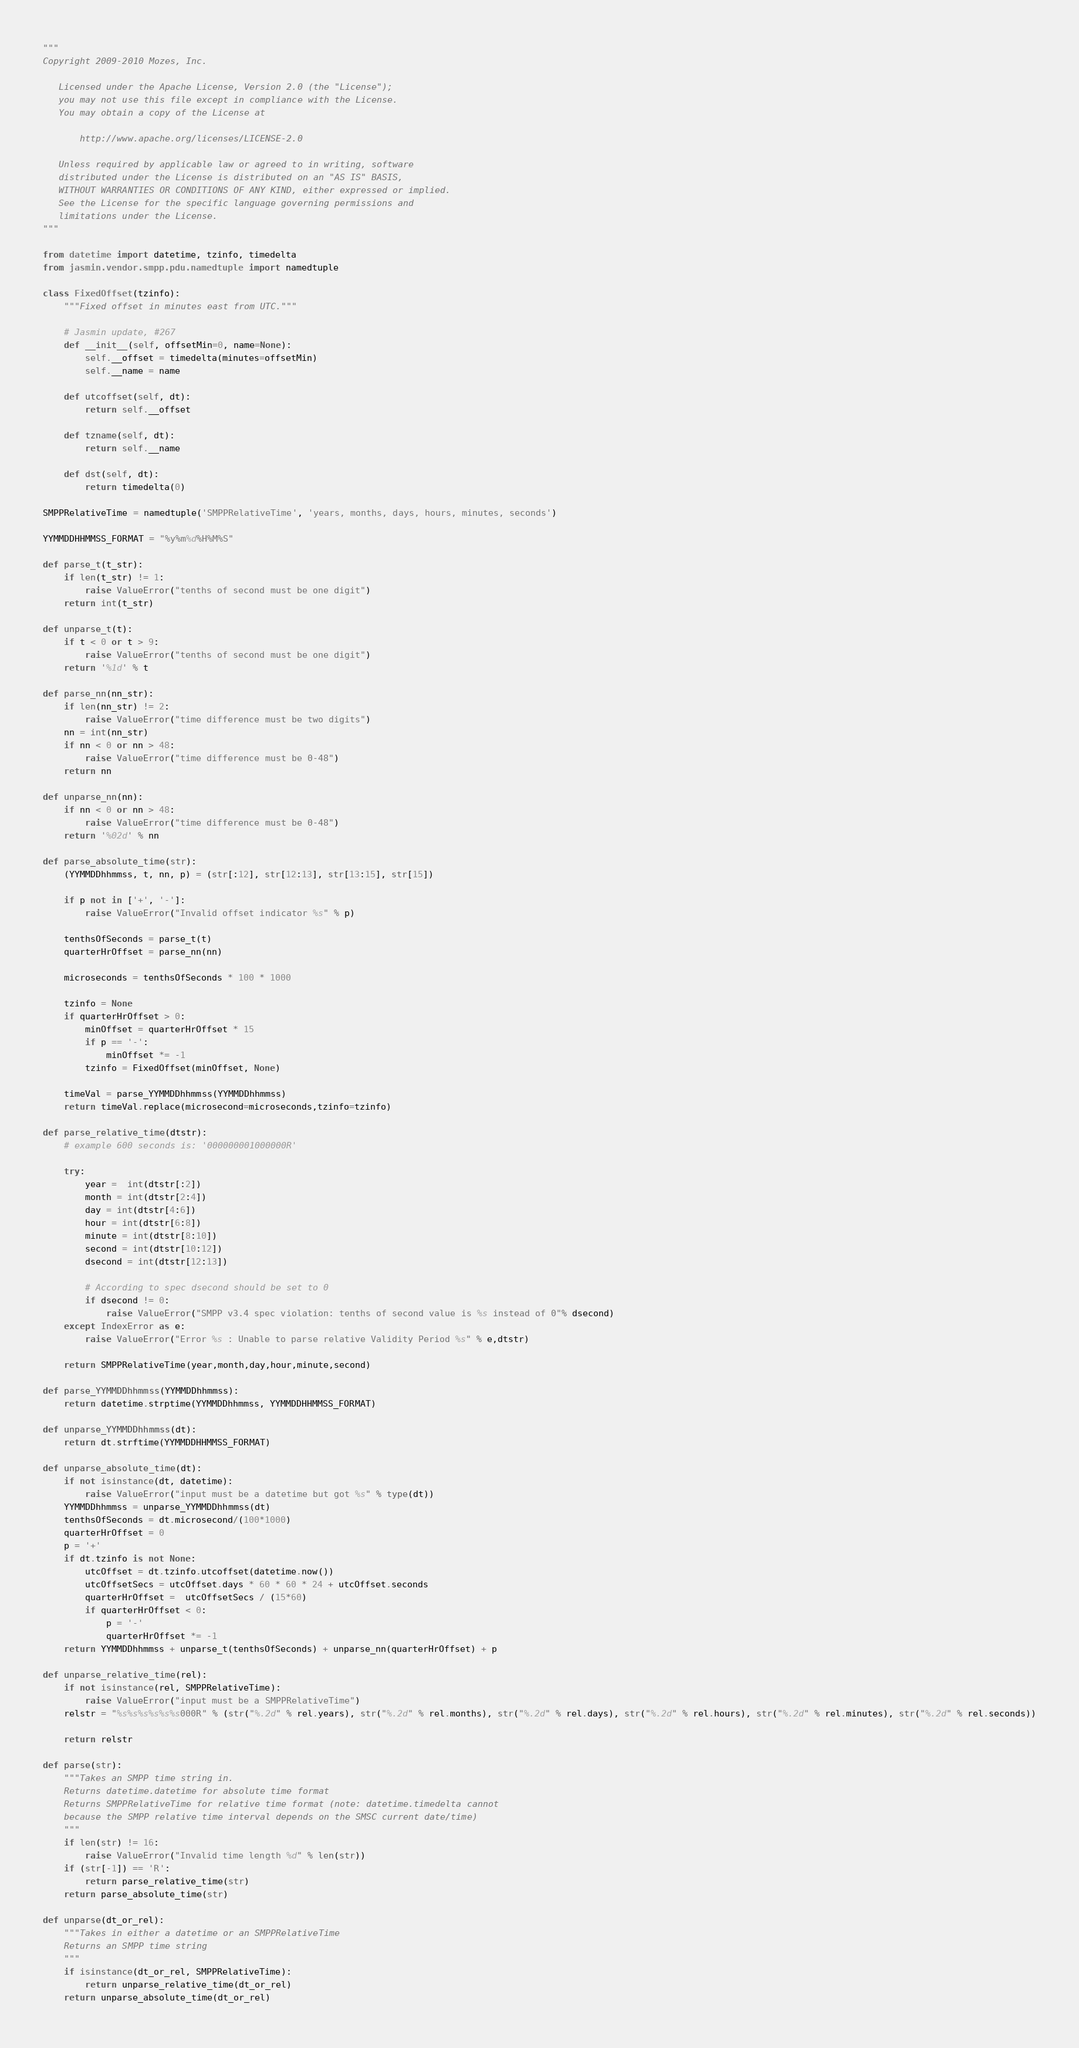<code> <loc_0><loc_0><loc_500><loc_500><_Python_>"""
Copyright 2009-2010 Mozes, Inc.

   Licensed under the Apache License, Version 2.0 (the "License");
   you may not use this file except in compliance with the License.
   You may obtain a copy of the License at

       http://www.apache.org/licenses/LICENSE-2.0

   Unless required by applicable law or agreed to in writing, software
   distributed under the License is distributed on an "AS IS" BASIS,
   WITHOUT WARRANTIES OR CONDITIONS OF ANY KIND, either expressed or implied.
   See the License for the specific language governing permissions and
   limitations under the License.
"""

from datetime import datetime, tzinfo, timedelta
from jasmin.vendor.smpp.pdu.namedtuple import namedtuple

class FixedOffset(tzinfo):
    """Fixed offset in minutes east from UTC."""

    # Jasmin update, #267
    def __init__(self, offsetMin=0, name=None):
        self.__offset = timedelta(minutes=offsetMin)
        self.__name = name

    def utcoffset(self, dt):
        return self.__offset

    def tzname(self, dt):
        return self.__name

    def dst(self, dt):
        return timedelta(0)

SMPPRelativeTime = namedtuple('SMPPRelativeTime', 'years, months, days, hours, minutes, seconds')

YYMMDDHHMMSS_FORMAT = "%y%m%d%H%M%S"

def parse_t(t_str):
    if len(t_str) != 1:
        raise ValueError("tenths of second must be one digit")
    return int(t_str)

def unparse_t(t):
    if t < 0 or t > 9:
        raise ValueError("tenths of second must be one digit")
    return '%1d' % t

def parse_nn(nn_str):
    if len(nn_str) != 2:
        raise ValueError("time difference must be two digits")
    nn = int(nn_str)
    if nn < 0 or nn > 48:
        raise ValueError("time difference must be 0-48")
    return nn

def unparse_nn(nn):
    if nn < 0 or nn > 48:
        raise ValueError("time difference must be 0-48")
    return '%02d' % nn

def parse_absolute_time(str):
    (YYMMDDhhmmss, t, nn, p) = (str[:12], str[12:13], str[13:15], str[15])

    if p not in ['+', '-']:
        raise ValueError("Invalid offset indicator %s" % p)

    tenthsOfSeconds = parse_t(t)
    quarterHrOffset = parse_nn(nn)

    microseconds = tenthsOfSeconds * 100 * 1000

    tzinfo = None
    if quarterHrOffset > 0:
        minOffset = quarterHrOffset * 15
        if p == '-':
            minOffset *= -1
        tzinfo = FixedOffset(minOffset, None)

    timeVal = parse_YYMMDDhhmmss(YYMMDDhhmmss)
    return timeVal.replace(microsecond=microseconds,tzinfo=tzinfo)

def parse_relative_time(dtstr):
    # example 600 seconds is: '000000001000000R'

    try:
        year =  int(dtstr[:2])
        month = int(dtstr[2:4])
        day = int(dtstr[4:6])
        hour = int(dtstr[6:8])
        minute = int(dtstr[8:10])
        second = int(dtstr[10:12])
        dsecond = int(dtstr[12:13])

        # According to spec dsecond should be set to 0
        if dsecond != 0:
            raise ValueError("SMPP v3.4 spec violation: tenths of second value is %s instead of 0"% dsecond)
    except IndexError as e:
        raise ValueError("Error %s : Unable to parse relative Validity Period %s" % e,dtstr)

    return SMPPRelativeTime(year,month,day,hour,minute,second)

def parse_YYMMDDhhmmss(YYMMDDhhmmss):
    return datetime.strptime(YYMMDDhhmmss, YYMMDDHHMMSS_FORMAT)

def unparse_YYMMDDhhmmss(dt):
    return dt.strftime(YYMMDDHHMMSS_FORMAT)

def unparse_absolute_time(dt):
    if not isinstance(dt, datetime):
        raise ValueError("input must be a datetime but got %s" % type(dt))
    YYMMDDhhmmss = unparse_YYMMDDhhmmss(dt)
    tenthsOfSeconds = dt.microsecond/(100*1000)
    quarterHrOffset = 0
    p = '+'
    if dt.tzinfo is not None:
        utcOffset = dt.tzinfo.utcoffset(datetime.now())
        utcOffsetSecs = utcOffset.days * 60 * 60 * 24 + utcOffset.seconds
        quarterHrOffset =  utcOffsetSecs / (15*60)
        if quarterHrOffset < 0:
            p = '-'
            quarterHrOffset *= -1
    return YYMMDDhhmmss + unparse_t(tenthsOfSeconds) + unparse_nn(quarterHrOffset) + p

def unparse_relative_time(rel):
    if not isinstance(rel, SMPPRelativeTime):
        raise ValueError("input must be a SMPPRelativeTime")
    relstr = "%s%s%s%s%s%s000R" % (str("%.2d" % rel.years), str("%.2d" % rel.months), str("%.2d" % rel.days), str("%.2d" % rel.hours), str("%.2d" % rel.minutes), str("%.2d" % rel.seconds))

    return relstr

def parse(str):
    """Takes an SMPP time string in.
    Returns datetime.datetime for absolute time format
    Returns SMPPRelativeTime for relative time format (note: datetime.timedelta cannot
    because the SMPP relative time interval depends on the SMSC current date/time)
    """
    if len(str) != 16:
        raise ValueError("Invalid time length %d" % len(str))
    if (str[-1]) == 'R':
        return parse_relative_time(str)
    return parse_absolute_time(str)

def unparse(dt_or_rel):
    """Takes in either a datetime or an SMPPRelativeTime
    Returns an SMPP time string
    """
    if isinstance(dt_or_rel, SMPPRelativeTime):
        return unparse_relative_time(dt_or_rel)
    return unparse_absolute_time(dt_or_rel)
</code> 